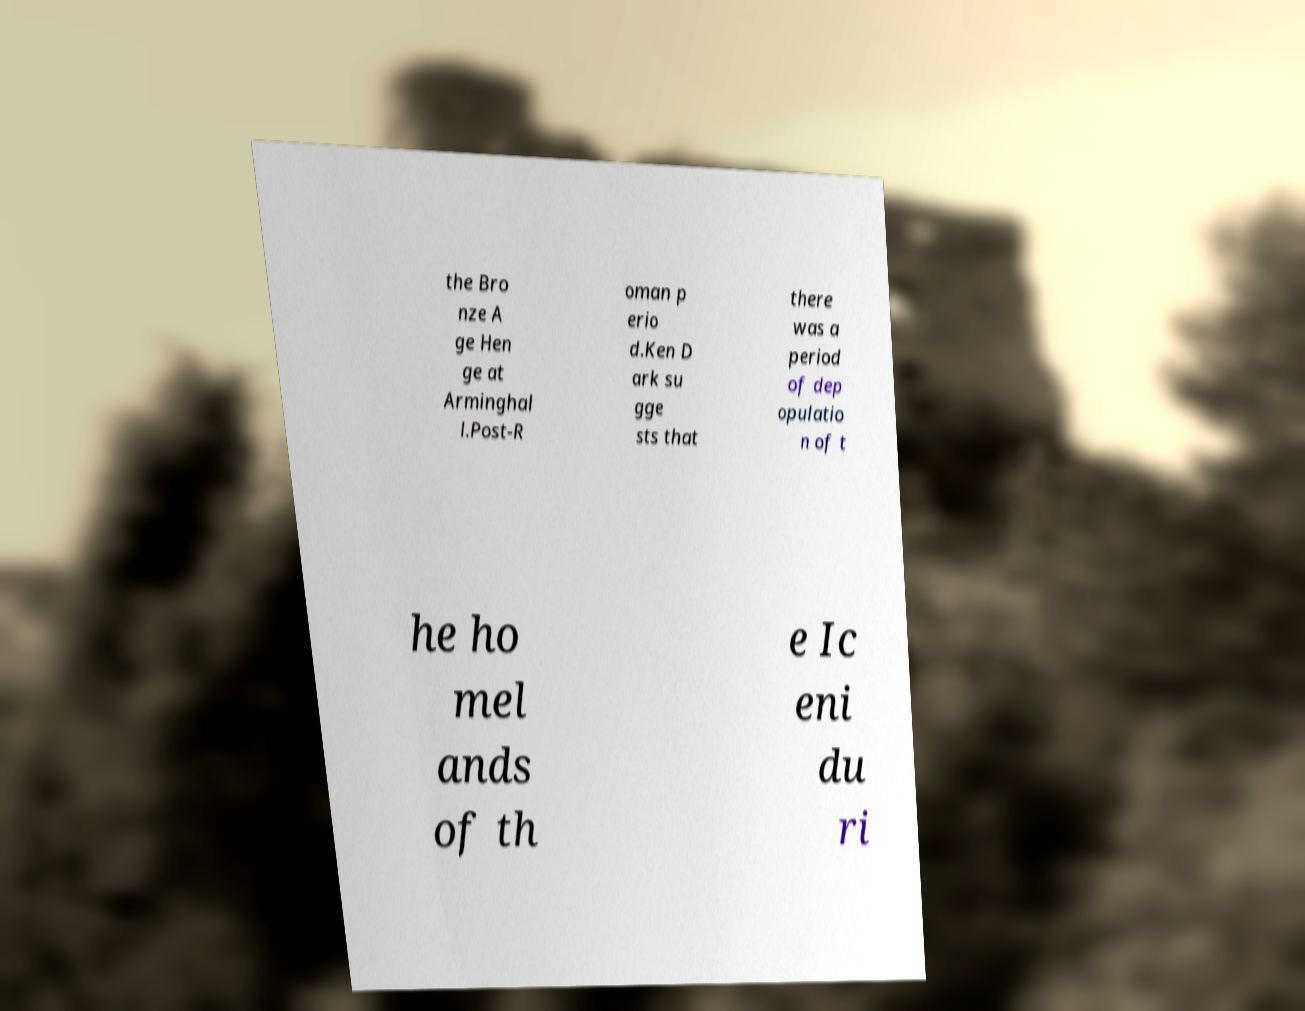Can you read and provide the text displayed in the image?This photo seems to have some interesting text. Can you extract and type it out for me? the Bro nze A ge Hen ge at Arminghal l.Post-R oman p erio d.Ken D ark su gge sts that there was a period of dep opulatio n of t he ho mel ands of th e Ic eni du ri 